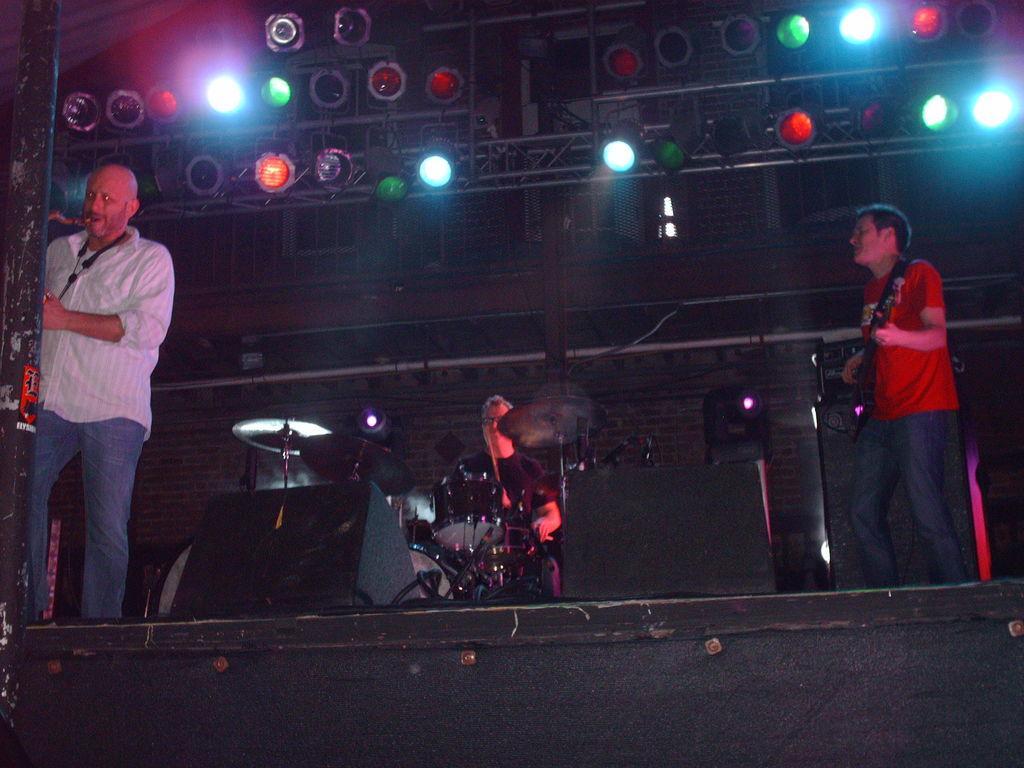How would you summarize this image in a sentence or two? In this image we can see few people playing musical instruments on the stage and there are few lights flashing from the roof. 